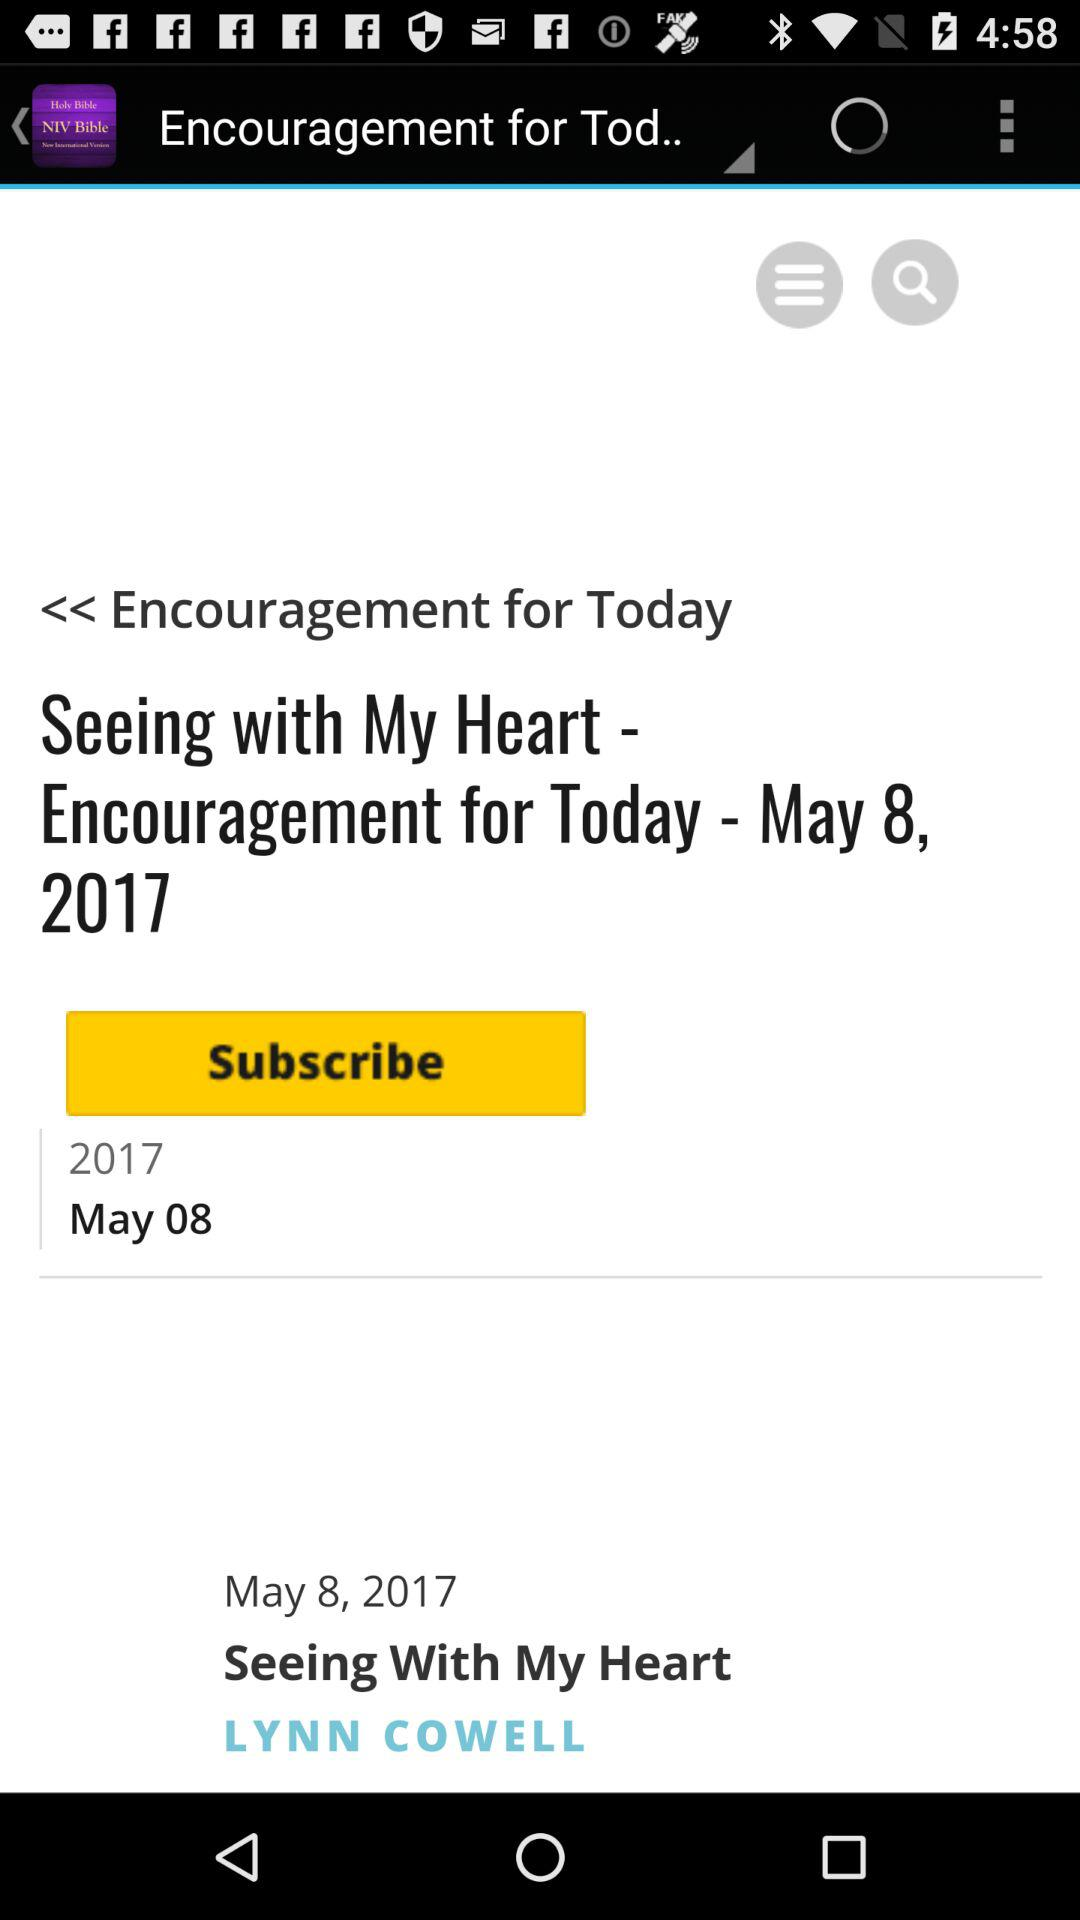Is personal information required to subscribe?
When the provided information is insufficient, respond with <no answer>. <no answer> 